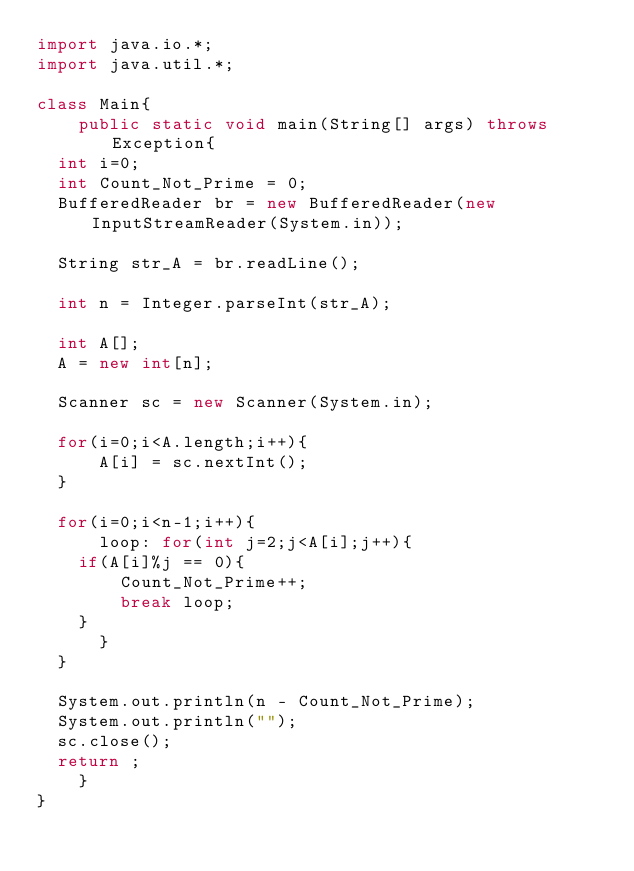<code> <loc_0><loc_0><loc_500><loc_500><_Java_>import java.io.*;
import java.util.*;

class Main{
    public static void main(String[] args) throws Exception{
	int i=0;
	int Count_Not_Prime = 0;
	BufferedReader br = new BufferedReader(new InputStreamReader(System.in));
	
	String str_A = br.readLine();
	
	int n = Integer.parseInt(str_A);
	
	int A[];
	A = new int[n];

	Scanner sc = new Scanner(System.in);
	
	for(i=0;i<A.length;i++){
	    A[i] = sc.nextInt();
	}
	
	for(i=0;i<n-1;i++){
	    loop: for(int j=2;j<A[i];j++){	
		if(A[i]%j == 0){
		    Count_Not_Prime++;
		    break loop;
		}
	    }
	}
	
	System.out.println(n - Count_Not_Prime);
	System.out.println("");
	sc.close();
	return ;
    }
}

</code> 